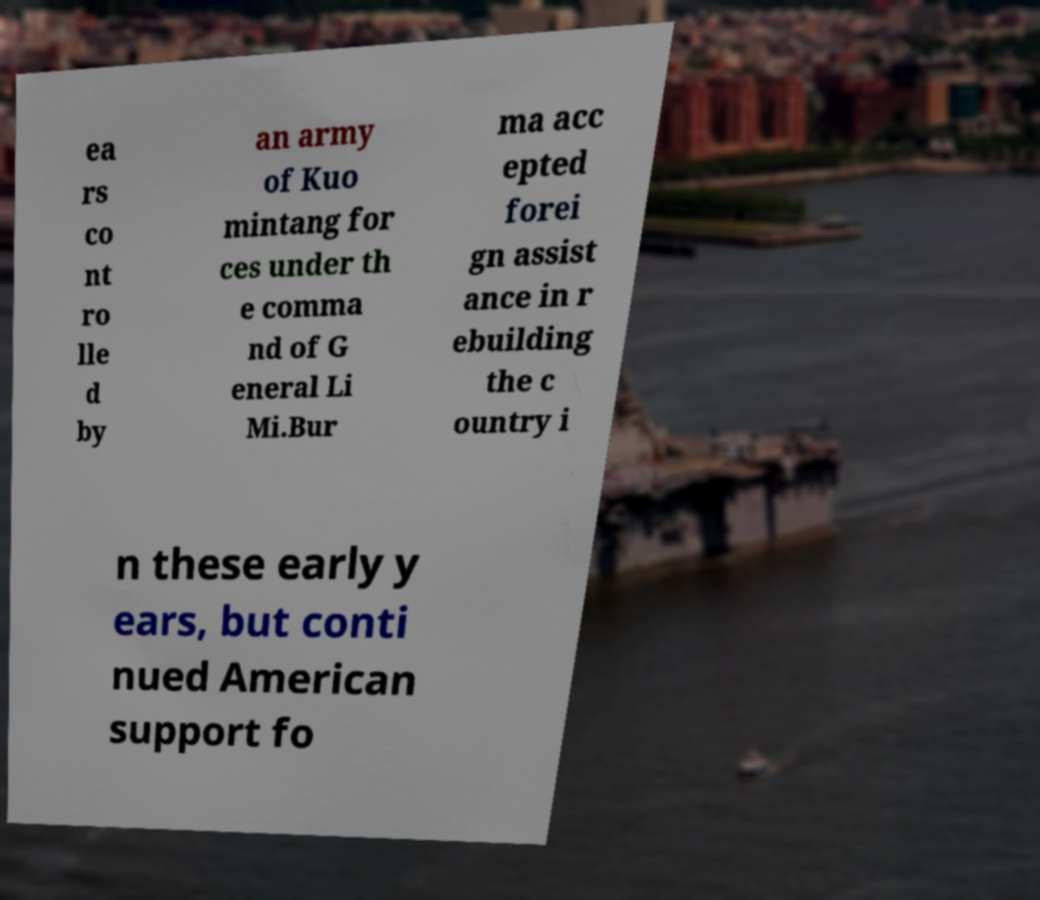Can you accurately transcribe the text from the provided image for me? ea rs co nt ro lle d by an army of Kuo mintang for ces under th e comma nd of G eneral Li Mi.Bur ma acc epted forei gn assist ance in r ebuilding the c ountry i n these early y ears, but conti nued American support fo 